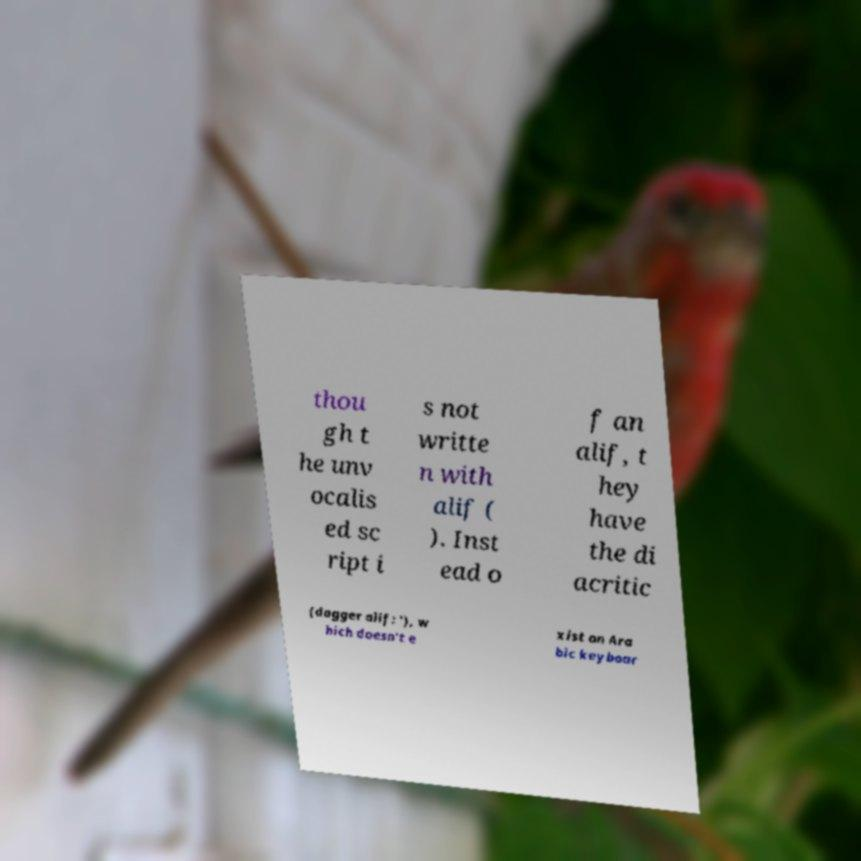There's text embedded in this image that I need extracted. Can you transcribe it verbatim? thou gh t he unv ocalis ed sc ript i s not writte n with alif ( ). Inst ead o f an alif, t hey have the di acritic (dagger alif: '), w hich doesn't e xist on Ara bic keyboar 